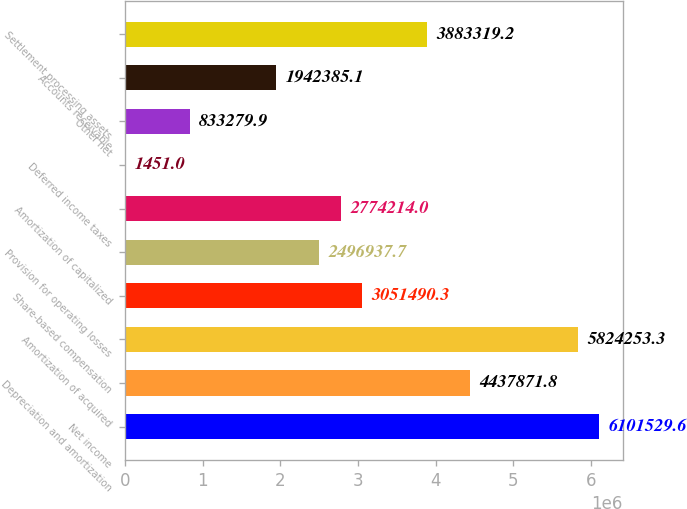Convert chart to OTSL. <chart><loc_0><loc_0><loc_500><loc_500><bar_chart><fcel>Net income<fcel>Depreciation and amortization<fcel>Amortization of acquired<fcel>Share-based compensation<fcel>Provision for operating losses<fcel>Amortization of capitalized<fcel>Deferred income taxes<fcel>Other net<fcel>Accounts receivable<fcel>Settlement processing assets<nl><fcel>6.10153e+06<fcel>4.43787e+06<fcel>5.82425e+06<fcel>3.05149e+06<fcel>2.49694e+06<fcel>2.77421e+06<fcel>1451<fcel>833280<fcel>1.94239e+06<fcel>3.88332e+06<nl></chart> 